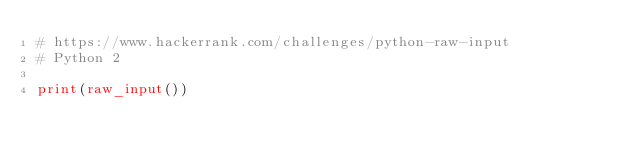<code> <loc_0><loc_0><loc_500><loc_500><_Python_># https://www.hackerrank.com/challenges/python-raw-input
# Python 2

print(raw_input())


</code> 